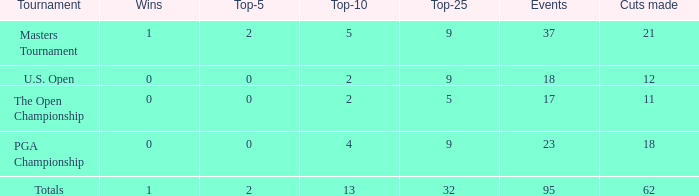What is the lowest top 5 winners with less than 0? None. 